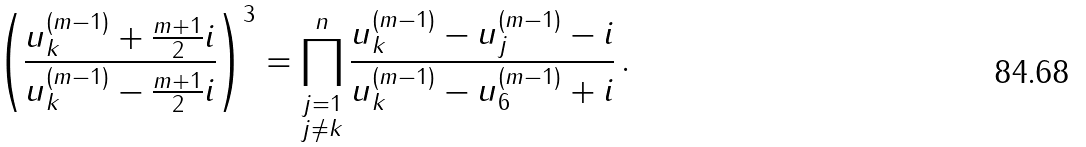<formula> <loc_0><loc_0><loc_500><loc_500>\left ( \frac { u ^ { ( m - 1 ) } _ { k } + \frac { m + 1 } { 2 } i } { u ^ { ( m - 1 ) } _ { k } - \frac { m + 1 } { 2 } i } \right ) ^ { 3 } = \prod ^ { n } _ { \substack { j = 1 \\ j \neq k } } \frac { u ^ { ( m - 1 ) } _ { k } - u ^ { ( m - 1 ) } _ { j } - i } { u ^ { ( m - 1 ) } _ { k } - u ^ { ( m - 1 ) } _ { 6 } + i } \, .</formula> 